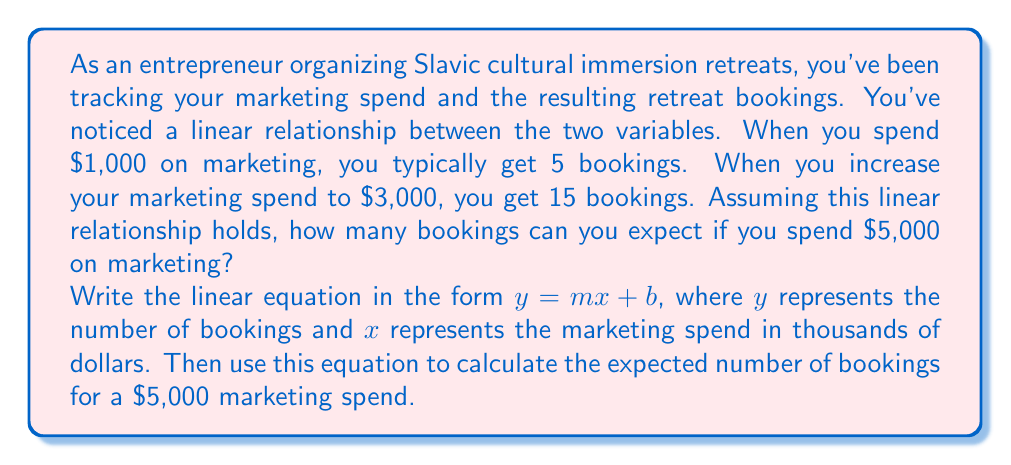Provide a solution to this math problem. Let's approach this step-by-step:

1) We know two points on this line:
   ($1, 5$) when spending $1,000 on marketing
   ($3, 15$) when spending $3,000 on marketing

2) We can use these points to find the slope (m) of the line:

   $m = \frac{y_2 - y_1}{x_2 - x_1} = \frac{15 - 5}{3 - 1} = \frac{10}{2} = 5$

3) This means for every $1,000 increase in marketing spend, we get 5 more bookings.

4) Now we can use the point-slope form of a line to find our equation:
   $y - y_1 = m(x - x_1)$
   $y - 5 = 5(x - 1)$

5) Simplify to slope-intercept form $(y = mx + b)$:
   $y = 5x + 0$

6) Therefore, our linear equation is $y = 5x$, where $x$ is in thousands of dollars.

7) To find the number of bookings for a $5,000 marketing spend, we plug in $x = 5$:
   $y = 5(5) = 25$
Answer: The linear equation is $y = 5x$, where $y$ is the number of bookings and $x$ is the marketing spend in thousands of dollars. For a $5,000 marketing spend, you can expect 25 bookings. 